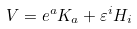<formula> <loc_0><loc_0><loc_500><loc_500>V = e ^ { a } K _ { a } + \varepsilon ^ { i } H _ { i } \,</formula> 